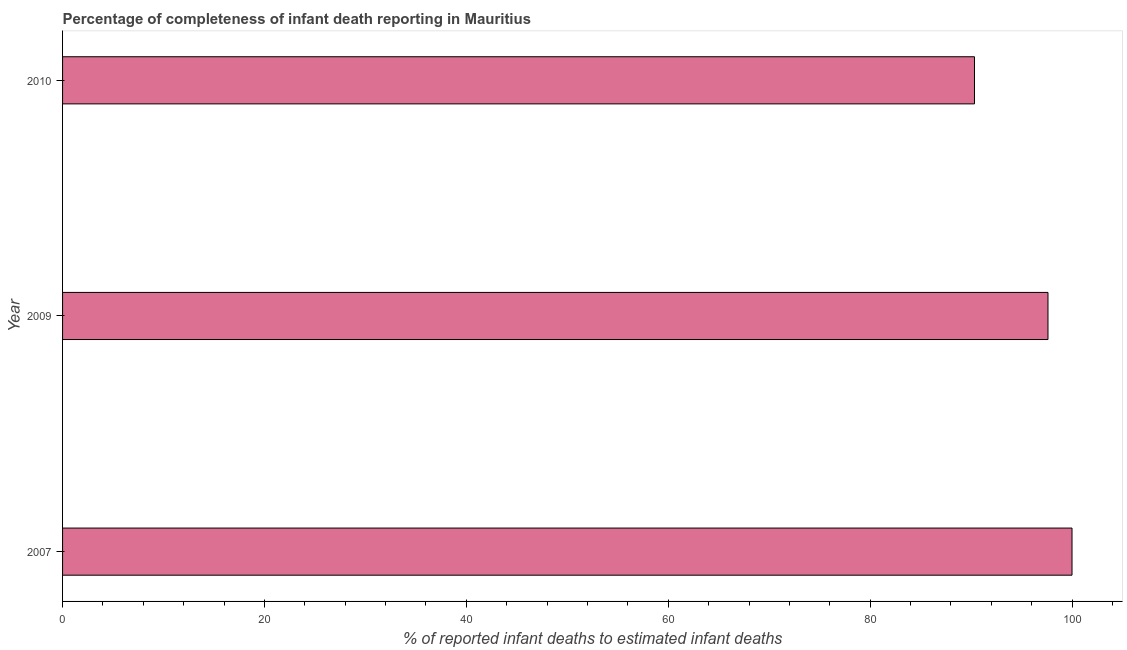What is the title of the graph?
Provide a succinct answer. Percentage of completeness of infant death reporting in Mauritius. What is the label or title of the X-axis?
Ensure brevity in your answer.  % of reported infant deaths to estimated infant deaths. What is the label or title of the Y-axis?
Your response must be concise. Year. What is the completeness of infant death reporting in 2009?
Your answer should be compact. 97.62. Across all years, what is the minimum completeness of infant death reporting?
Your answer should be very brief. 90.34. What is the sum of the completeness of infant death reporting?
Provide a succinct answer. 287.96. What is the difference between the completeness of infant death reporting in 2007 and 2010?
Offer a very short reply. 9.66. What is the average completeness of infant death reporting per year?
Your answer should be compact. 95.99. What is the median completeness of infant death reporting?
Provide a short and direct response. 97.62. Do a majority of the years between 2010 and 2007 (inclusive) have completeness of infant death reporting greater than 60 %?
Offer a terse response. Yes. What is the ratio of the completeness of infant death reporting in 2007 to that in 2010?
Provide a short and direct response. 1.11. Is the difference between the completeness of infant death reporting in 2009 and 2010 greater than the difference between any two years?
Provide a short and direct response. No. What is the difference between the highest and the second highest completeness of infant death reporting?
Give a very brief answer. 2.38. What is the difference between the highest and the lowest completeness of infant death reporting?
Your response must be concise. 9.66. How many bars are there?
Your answer should be compact. 3. Are all the bars in the graph horizontal?
Your answer should be very brief. Yes. How many years are there in the graph?
Keep it short and to the point. 3. Are the values on the major ticks of X-axis written in scientific E-notation?
Offer a very short reply. No. What is the % of reported infant deaths to estimated infant deaths of 2007?
Give a very brief answer. 100. What is the % of reported infant deaths to estimated infant deaths in 2009?
Provide a short and direct response. 97.62. What is the % of reported infant deaths to estimated infant deaths in 2010?
Your response must be concise. 90.34. What is the difference between the % of reported infant deaths to estimated infant deaths in 2007 and 2009?
Provide a succinct answer. 2.38. What is the difference between the % of reported infant deaths to estimated infant deaths in 2007 and 2010?
Make the answer very short. 9.66. What is the difference between the % of reported infant deaths to estimated infant deaths in 2009 and 2010?
Provide a succinct answer. 7.28. What is the ratio of the % of reported infant deaths to estimated infant deaths in 2007 to that in 2010?
Your answer should be compact. 1.11. What is the ratio of the % of reported infant deaths to estimated infant deaths in 2009 to that in 2010?
Ensure brevity in your answer.  1.08. 